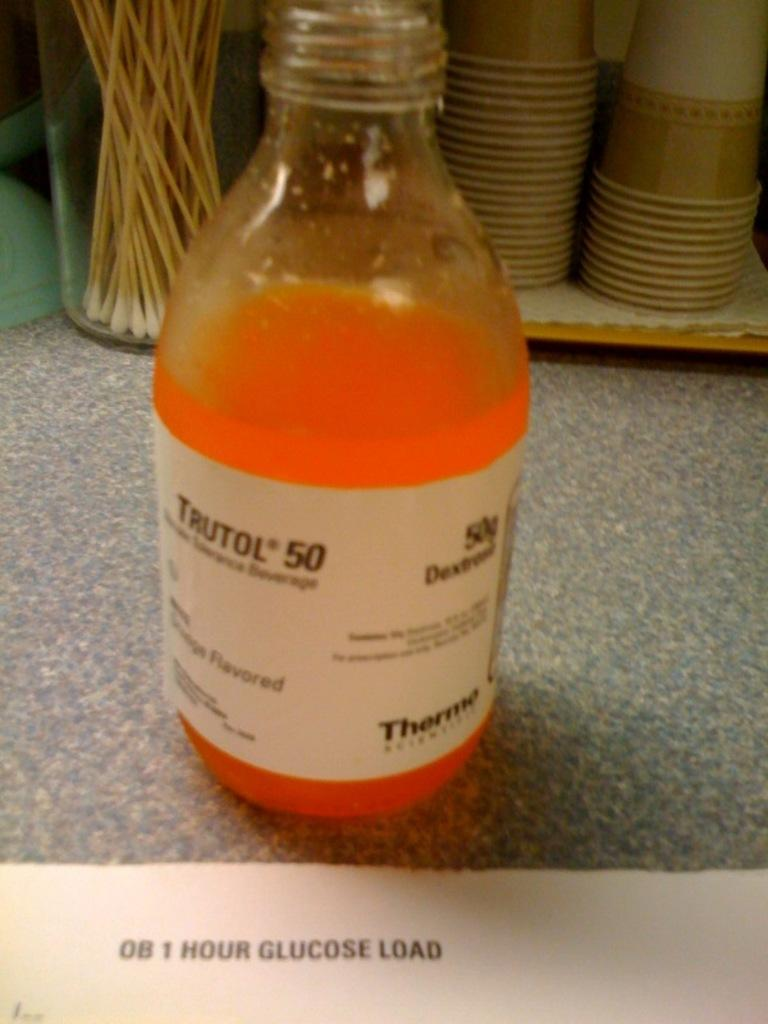Provide a one-sentence caption for the provided image. A bottle of Trutol gluclose drink is sitting in front of paper cups. 